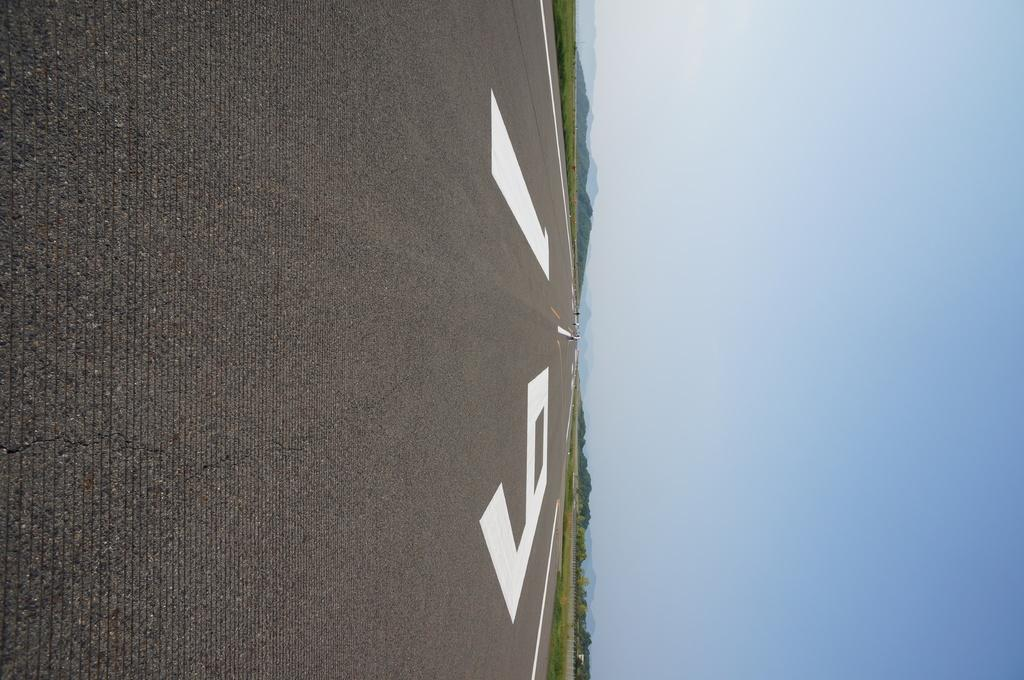What can be seen on the left side of the image? There is a road on the left side of the image. What is visible on the right side of the image? The sky is visible on the right side of the image. Can you describe the road in the image? The facts provided do not give any specific details about the road, so we cannot describe it further. What type of substance is being watched by the slave in the image? There is no substance, watch, or slave present in the image. 